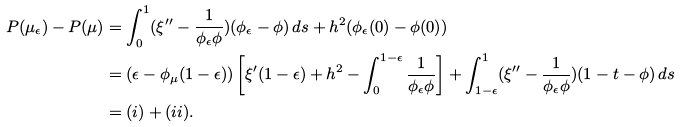Convert formula to latex. <formula><loc_0><loc_0><loc_500><loc_500>P ( \mu _ { \epsilon } ) - P ( \mu ) & = \int _ { 0 } ^ { 1 } ( \xi ^ { \prime \prime } - \frac { 1 } { \phi _ { \epsilon } \phi } ) ( \phi _ { \epsilon } - \phi ) \, d s + h ^ { 2 } ( \phi _ { \epsilon } ( 0 ) - \phi ( 0 ) ) \\ & = ( \epsilon - \phi _ { \mu } ( 1 - \epsilon ) ) \left [ \xi ^ { \prime } ( 1 - \epsilon ) + h ^ { 2 } - \int _ { 0 } ^ { 1 - \epsilon } \frac { 1 } { \phi _ { \epsilon } \phi } \right ] + \int _ { 1 - \epsilon } ^ { 1 } ( \xi ^ { \prime \prime } - \frac { 1 } { \phi _ { \epsilon } \phi } ) ( 1 - t - \phi ) \, d s \\ & = ( i ) + ( i i ) .</formula> 